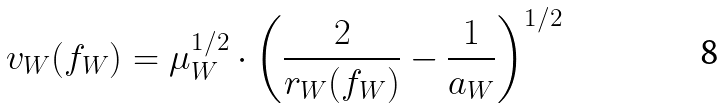<formula> <loc_0><loc_0><loc_500><loc_500>v _ { W } ( f _ { W } ) = \mu _ { W } ^ { 1 / 2 } \cdot \left ( \frac { 2 } { r _ { W } ( f _ { W } ) } - \frac { 1 } { a _ { W } } \right ) ^ { 1 / 2 }</formula> 